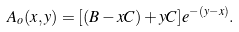<formula> <loc_0><loc_0><loc_500><loc_500>A _ { o } ( x , y ) = [ ( B - x C ) + y C ] e ^ { - ( y - x ) } .</formula> 